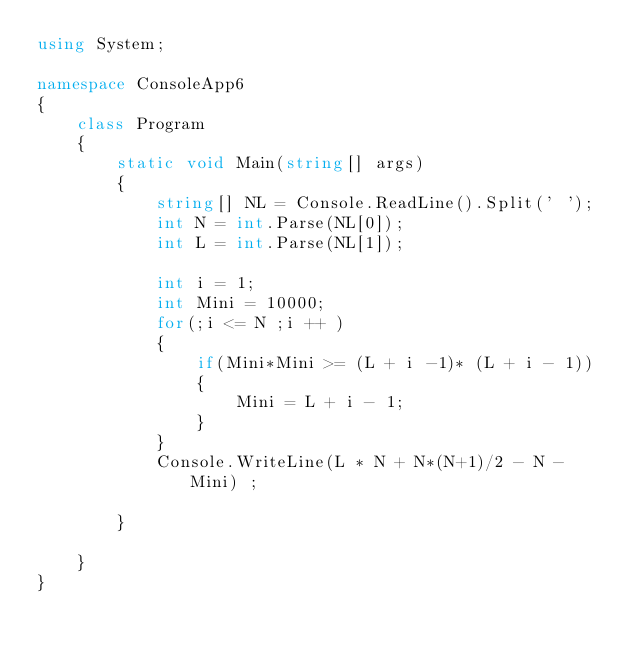<code> <loc_0><loc_0><loc_500><loc_500><_C#_>using System;

namespace ConsoleApp6
{
    class Program
    {
        static void Main(string[] args)
        {
            string[] NL = Console.ReadLine().Split(' ');
            int N = int.Parse(NL[0]);
            int L = int.Parse(NL[1]);

            int i = 1;
            int Mini = 10000;
            for(;i <= N ;i ++ )
            {
                if(Mini*Mini >= (L + i -1)* (L + i - 1))
                {
                    Mini = L + i - 1;
                }
            }
            Console.WriteLine(L * N + N*(N+1)/2 - N - Mini) ;

        }

    }
}
</code> 